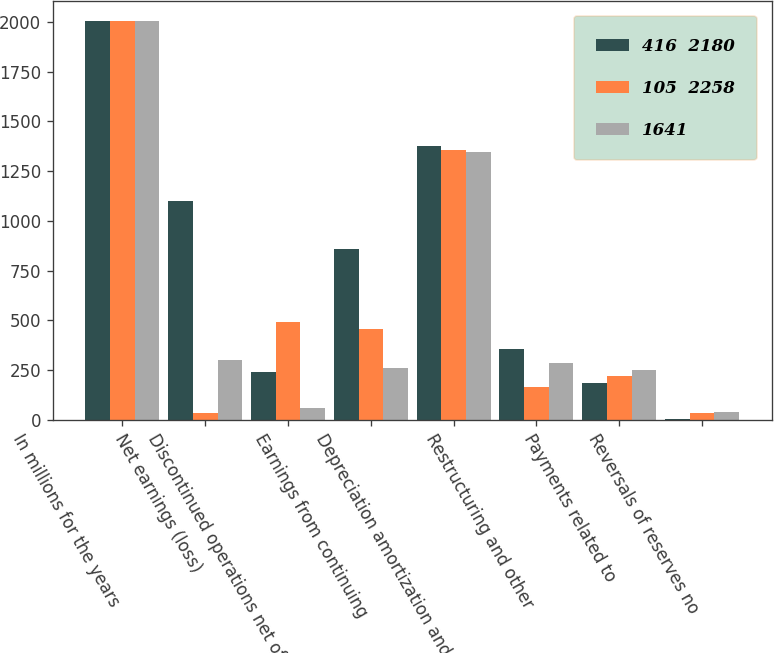<chart> <loc_0><loc_0><loc_500><loc_500><stacked_bar_chart><ecel><fcel>In millions for the years<fcel>Net earnings (loss)<fcel>Discontinued operations net of<fcel>Earnings from continuing<fcel>Depreciation amortization and<fcel>Restructuring and other<fcel>Payments related to<fcel>Reversals of reserves no<nl><fcel>416  2180<fcel>2005<fcel>1100<fcel>241<fcel>859<fcel>1376<fcel>358<fcel>185<fcel>4<nl><fcel>105  2258<fcel>2004<fcel>35<fcel>491<fcel>456<fcel>1357<fcel>166<fcel>220<fcel>36<nl><fcel>1641<fcel>2003<fcel>302<fcel>57<fcel>258<fcel>1347<fcel>286<fcel>252<fcel>39<nl></chart> 